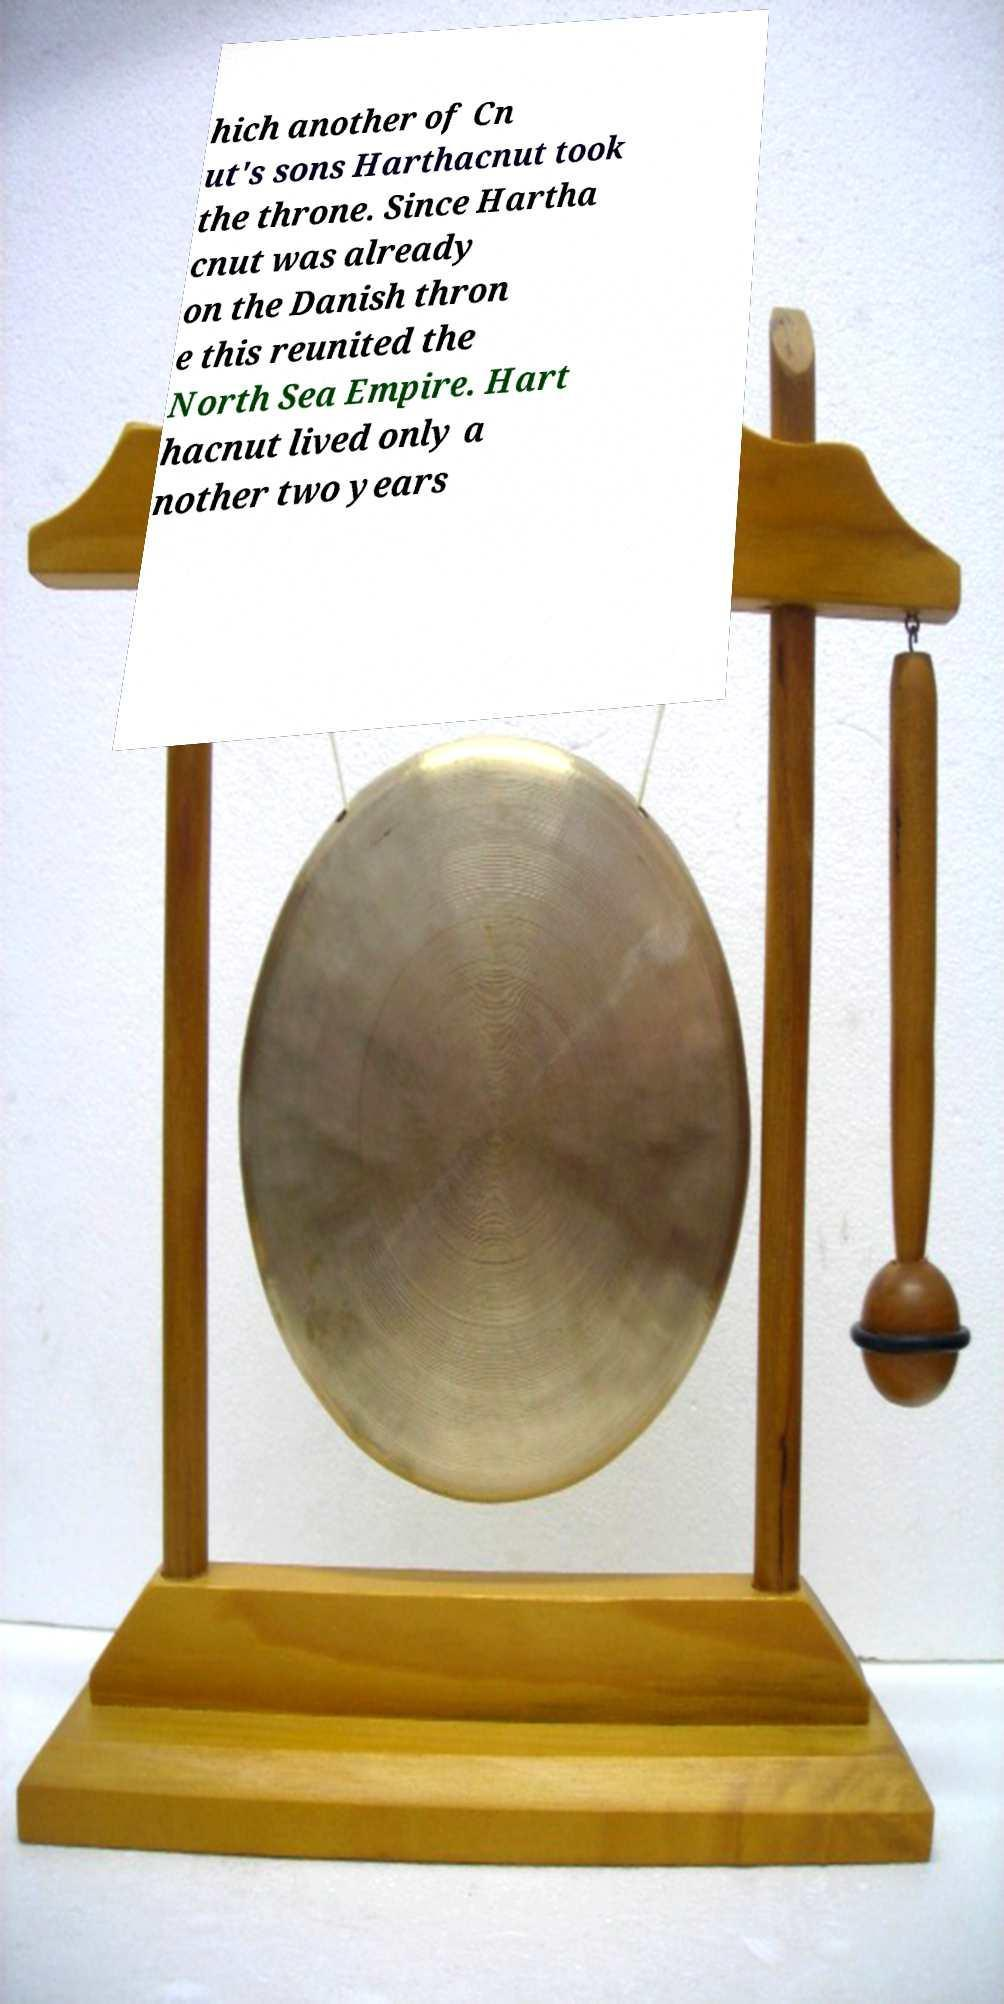Could you extract and type out the text from this image? hich another of Cn ut's sons Harthacnut took the throne. Since Hartha cnut was already on the Danish thron e this reunited the North Sea Empire. Hart hacnut lived only a nother two years 